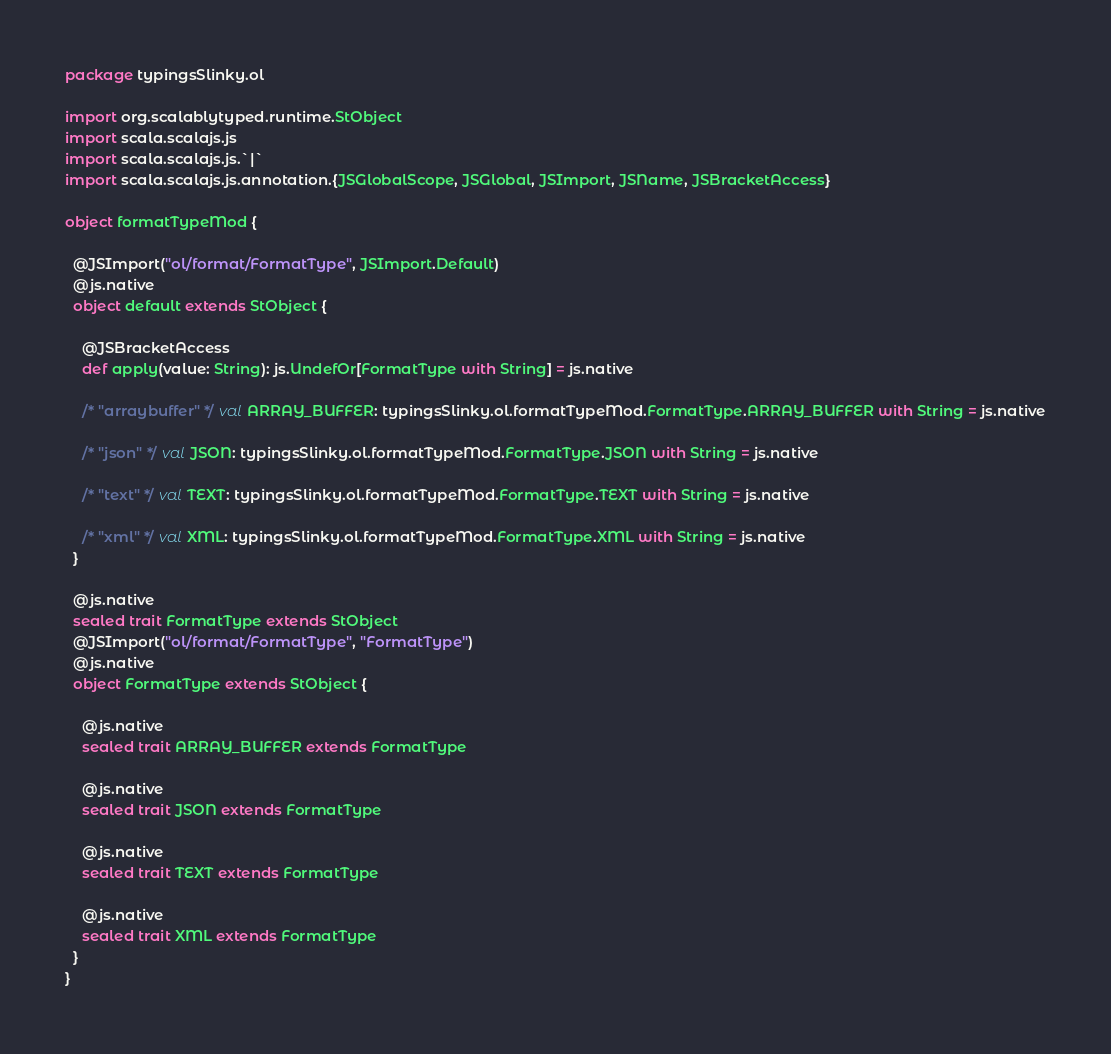<code> <loc_0><loc_0><loc_500><loc_500><_Scala_>package typingsSlinky.ol

import org.scalablytyped.runtime.StObject
import scala.scalajs.js
import scala.scalajs.js.`|`
import scala.scalajs.js.annotation.{JSGlobalScope, JSGlobal, JSImport, JSName, JSBracketAccess}

object formatTypeMod {
  
  @JSImport("ol/format/FormatType", JSImport.Default)
  @js.native
  object default extends StObject {
    
    @JSBracketAccess
    def apply(value: String): js.UndefOr[FormatType with String] = js.native
    
    /* "arraybuffer" */ val ARRAY_BUFFER: typingsSlinky.ol.formatTypeMod.FormatType.ARRAY_BUFFER with String = js.native
    
    /* "json" */ val JSON: typingsSlinky.ol.formatTypeMod.FormatType.JSON with String = js.native
    
    /* "text" */ val TEXT: typingsSlinky.ol.formatTypeMod.FormatType.TEXT with String = js.native
    
    /* "xml" */ val XML: typingsSlinky.ol.formatTypeMod.FormatType.XML with String = js.native
  }
  
  @js.native
  sealed trait FormatType extends StObject
  @JSImport("ol/format/FormatType", "FormatType")
  @js.native
  object FormatType extends StObject {
    
    @js.native
    sealed trait ARRAY_BUFFER extends FormatType
    
    @js.native
    sealed trait JSON extends FormatType
    
    @js.native
    sealed trait TEXT extends FormatType
    
    @js.native
    sealed trait XML extends FormatType
  }
}
</code> 